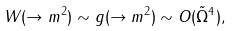<formula> <loc_0><loc_0><loc_500><loc_500>W ( \to m ^ { 2 } ) \sim g ( \to m ^ { 2 } ) \sim O ( \tilde { \Omega } ^ { 4 } ) ,</formula> 